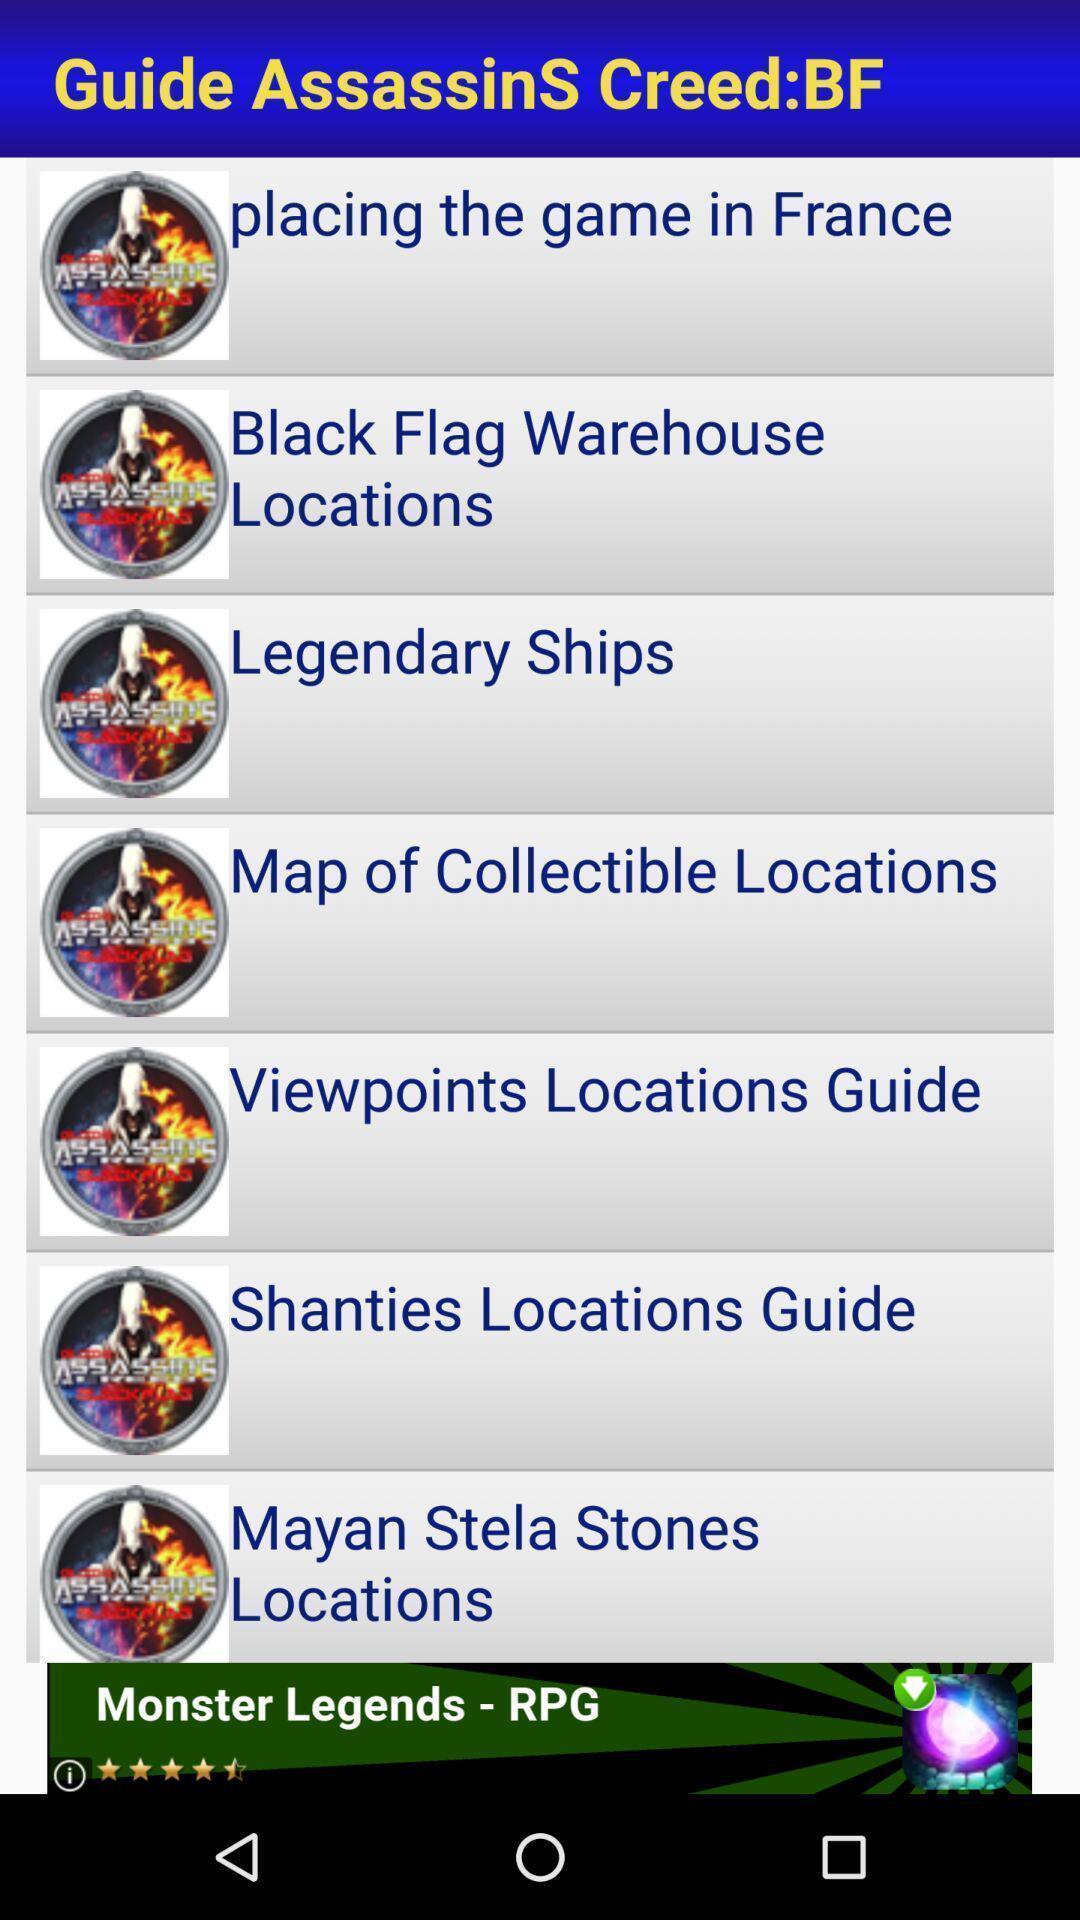What details can you identify in this image? Window displaying list of games. 